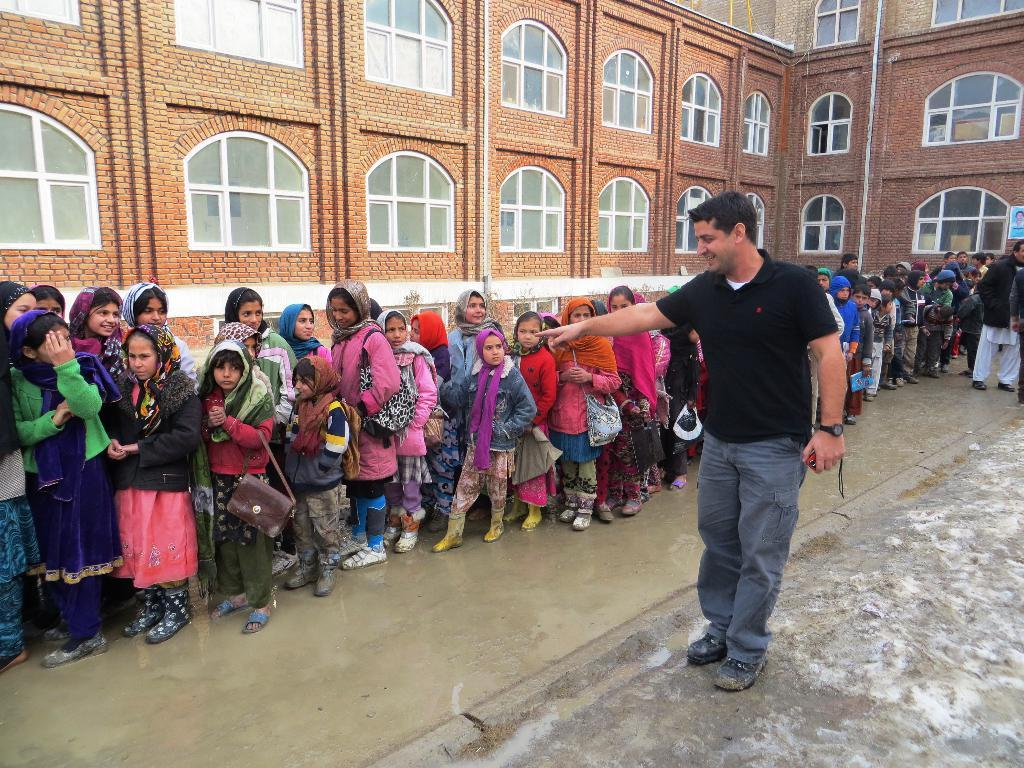Who or what can be seen in the image? There are people in the image. What architectural feature is visible in the image? There is a building in the image. What can be seen through the windows in the image? The presence of windows suggests that there may be a view of the surroundings, but the specifics cannot be determined from the provided facts. What is on the wall in the image? There is a poster on a wall in the image. What type of bag does the father carry in the image? There is no mention of a father or a bag in the image, so this information cannot be determined. 